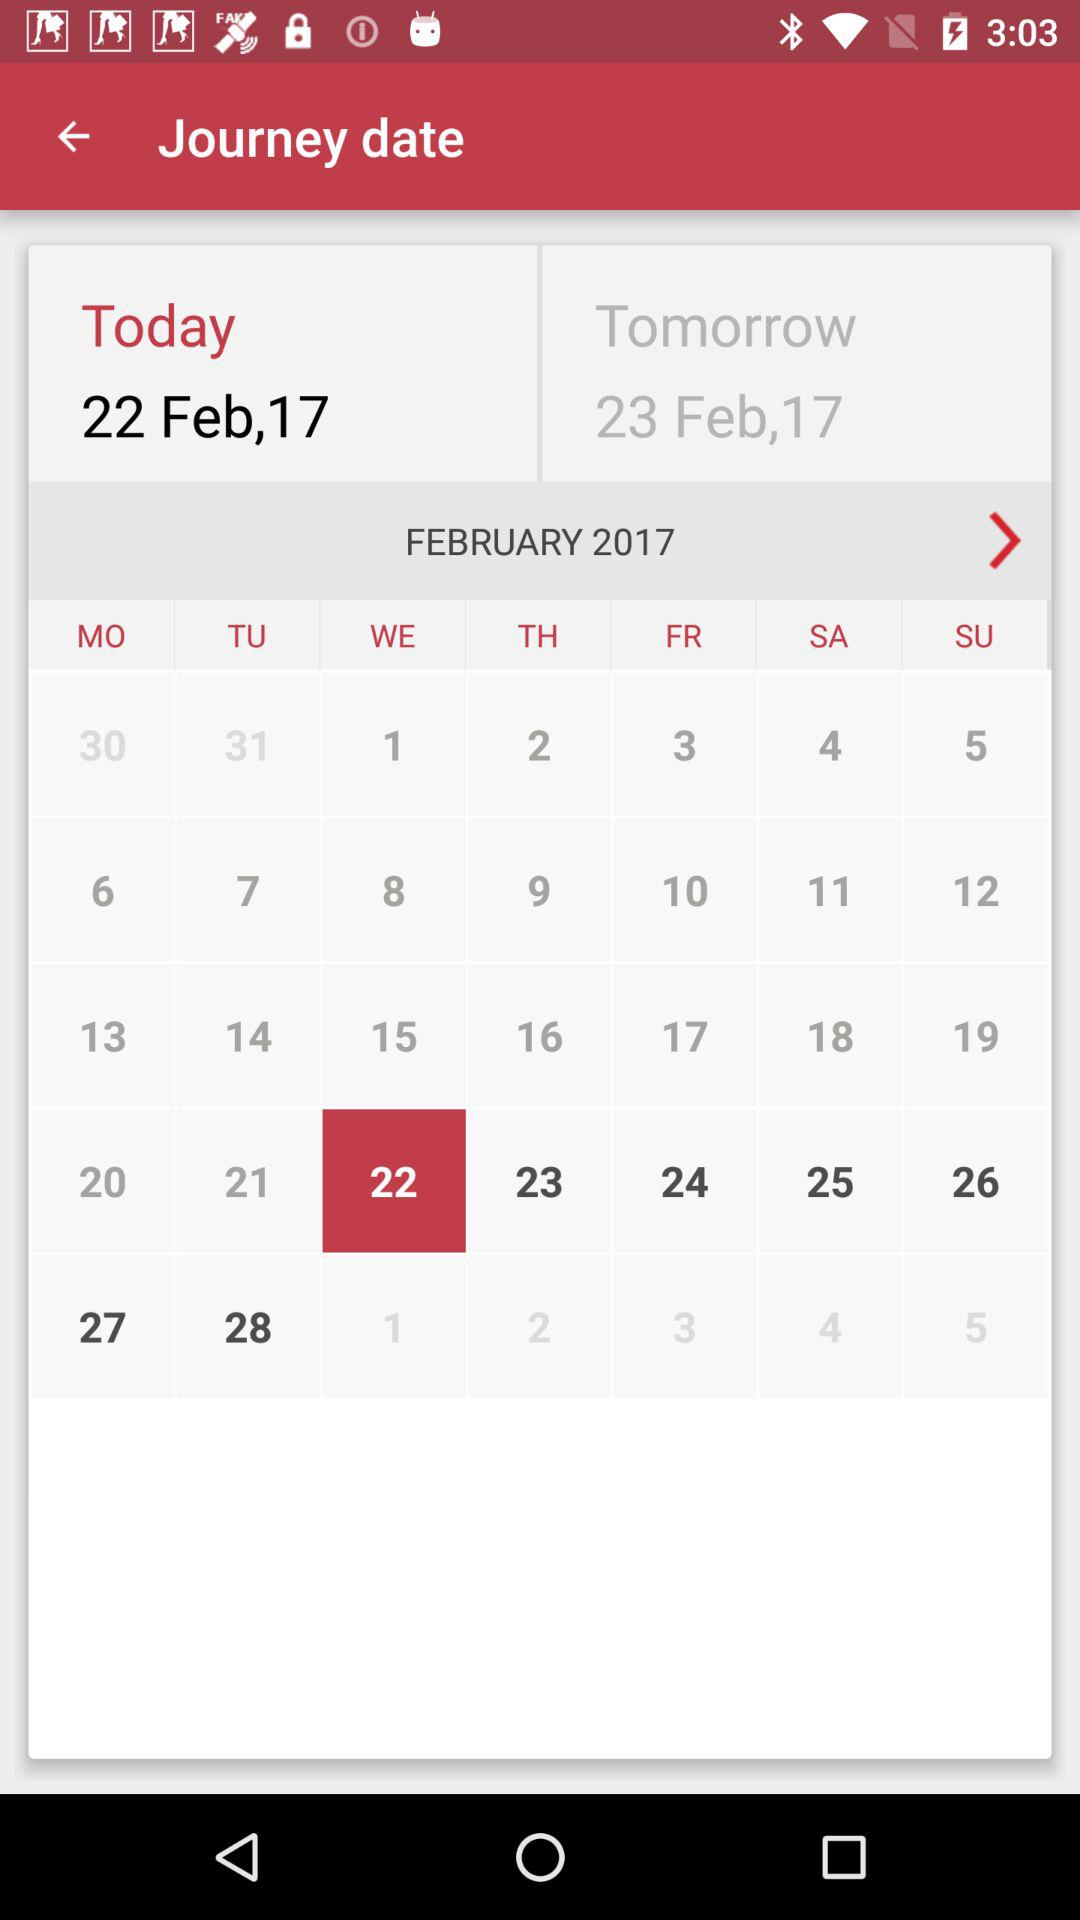What date is highlighted in the calendar? The highlighted date is Wednesday, 22 February, 2017. 